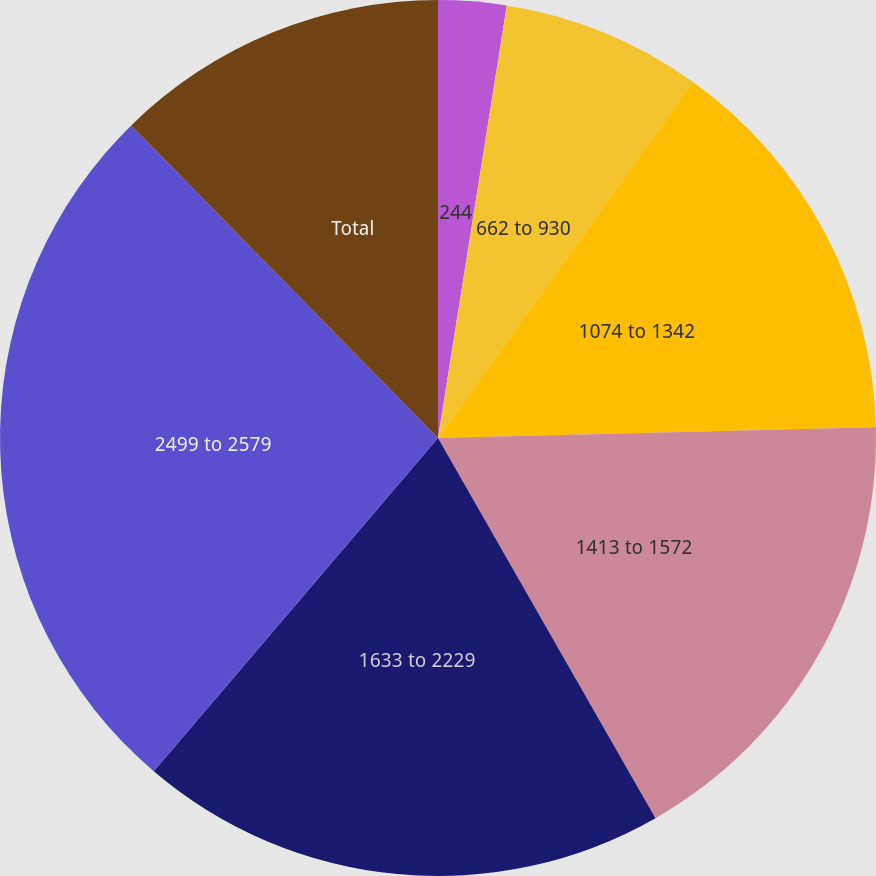<chart> <loc_0><loc_0><loc_500><loc_500><pie_chart><fcel>244<fcel>662 to 930<fcel>1074 to 1342<fcel>1413 to 1572<fcel>1633 to 2229<fcel>2499 to 2579<fcel>Total<nl><fcel>2.51%<fcel>7.37%<fcel>14.73%<fcel>17.12%<fcel>19.51%<fcel>26.41%<fcel>12.35%<nl></chart> 